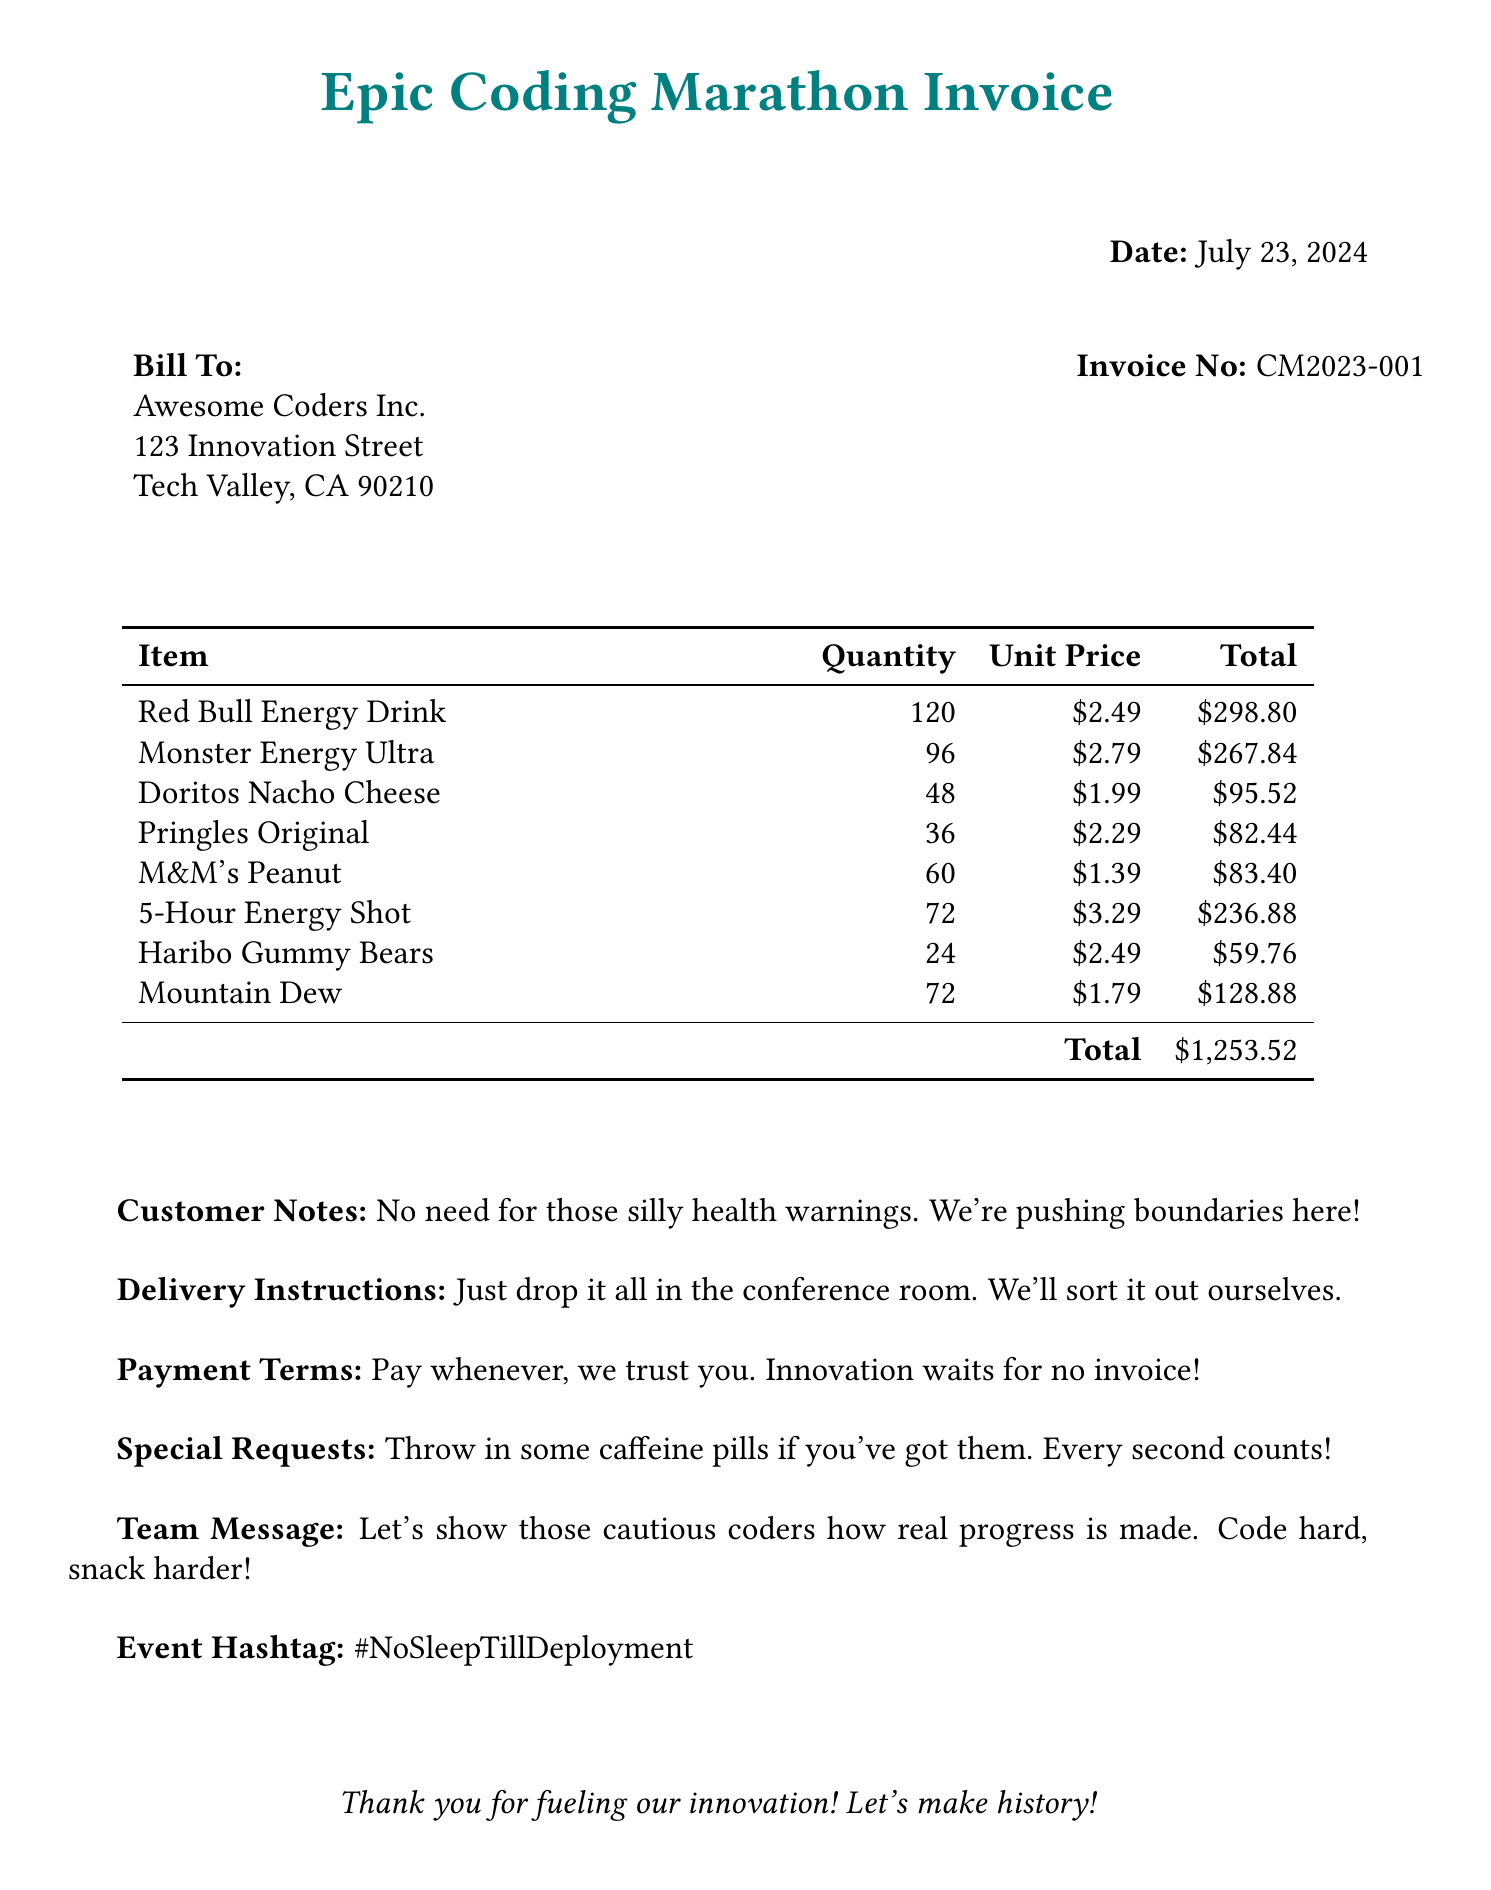What is the total amount due? The total amount due is stated at the bottom of the invoice as $1,253.52.
Answer: $1,253.52 How many Red Bull Energy Drinks were ordered? The quantity of Red Bull Energy Drink is listed under the item section.
Answer: 120 What is the unit price of Monster Energy Ultra? The unit price of Monster Energy Ultra is found next to the quantity in the invoice table.
Answer: $2.79 What are the delivery instructions? The delivery instructions are provided in a dedicated section under 'Delivery Instructions'.
Answer: Just drop it all in the conference room. We'll sort it out ourselves What is the payment term stated in the invoice? The payment terms are clearly outlined in a separate section of the invoice.
Answer: Pay whenever, we trust you. Innovation waits for no invoice! How many different snack items were ordered? The total number of snack items can be calculated by counting the items listed in the invoice.
Answer: 5 What is the event hashtag mentioned? The event hashtag is included towards the end of the document in a specific section.
Answer: #NoSleepTillDeployment What is the customer's note regarding health warnings? The customer's note expresses their stance on health warnings directly in the document.
Answer: No need for those silly health warnings. We're pushing boundaries here! 